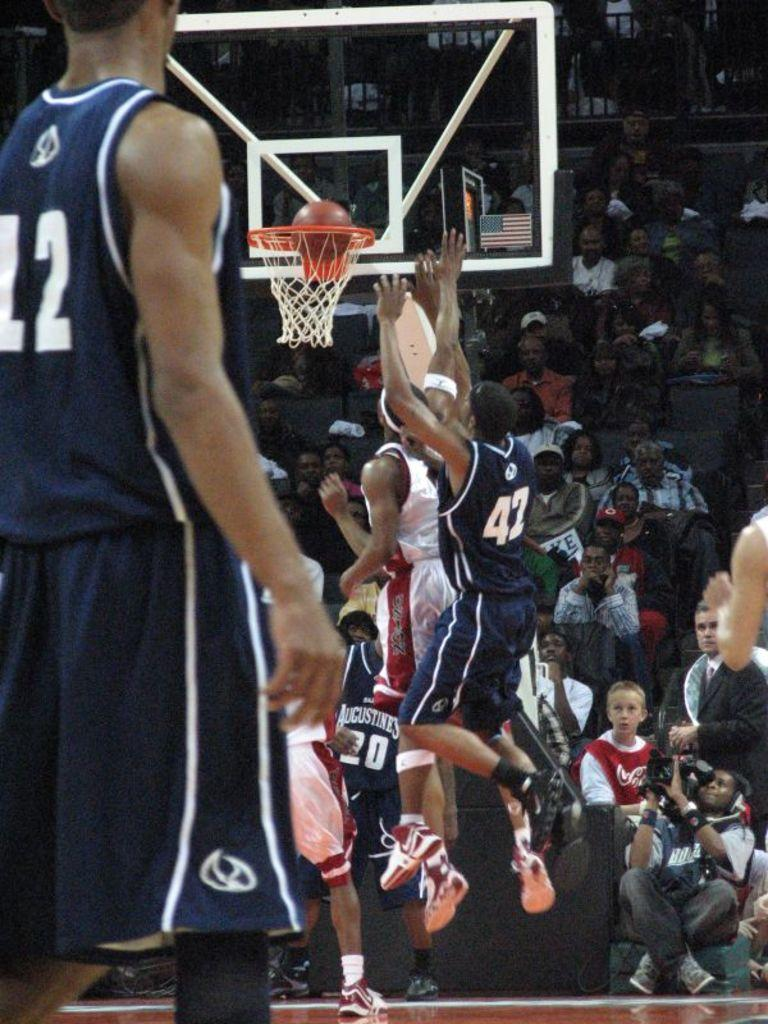What activity are the people in the image engaged in? The people in the image are playing basketball. Can you describe the setting of the image? In the background of the image, there are people sitting. What type of wilderness can be seen in the image? There is no wilderness present in the image; it features people playing basketball and sitting in the background. How many toes can be seen on the basketball players in the image? The number of toes cannot be determined from the image, as it only shows the players from the waist up. 